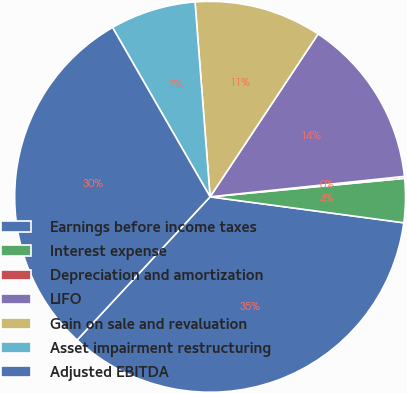<chart> <loc_0><loc_0><loc_500><loc_500><pie_chart><fcel>Earnings before income taxes<fcel>Interest expense<fcel>Depreciation and amortization<fcel>LIFO<fcel>Gain on sale and revaluation<fcel>Asset impairment restructuring<fcel>Adjusted EBITDA<nl><fcel>34.79%<fcel>3.63%<fcel>0.16%<fcel>14.01%<fcel>10.55%<fcel>7.09%<fcel>29.77%<nl></chart> 